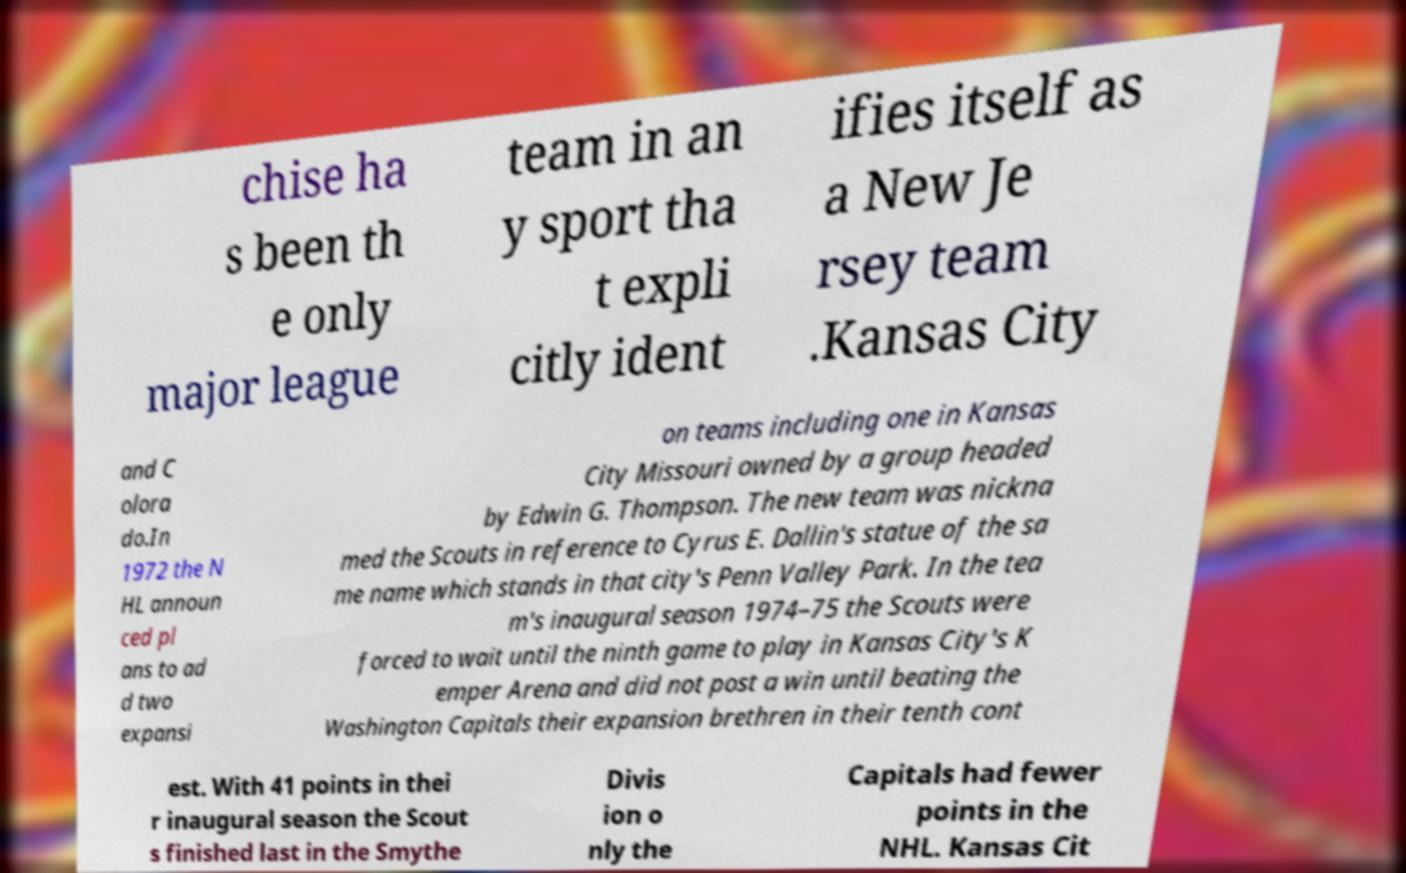For documentation purposes, I need the text within this image transcribed. Could you provide that? chise ha s been th e only major league team in an y sport tha t expli citly ident ifies itself as a New Je rsey team .Kansas City and C olora do.In 1972 the N HL announ ced pl ans to ad d two expansi on teams including one in Kansas City Missouri owned by a group headed by Edwin G. Thompson. The new team was nickna med the Scouts in reference to Cyrus E. Dallin's statue of the sa me name which stands in that city's Penn Valley Park. In the tea m's inaugural season 1974–75 the Scouts were forced to wait until the ninth game to play in Kansas City's K emper Arena and did not post a win until beating the Washington Capitals their expansion brethren in their tenth cont est. With 41 points in thei r inaugural season the Scout s finished last in the Smythe Divis ion o nly the Capitals had fewer points in the NHL. Kansas Cit 